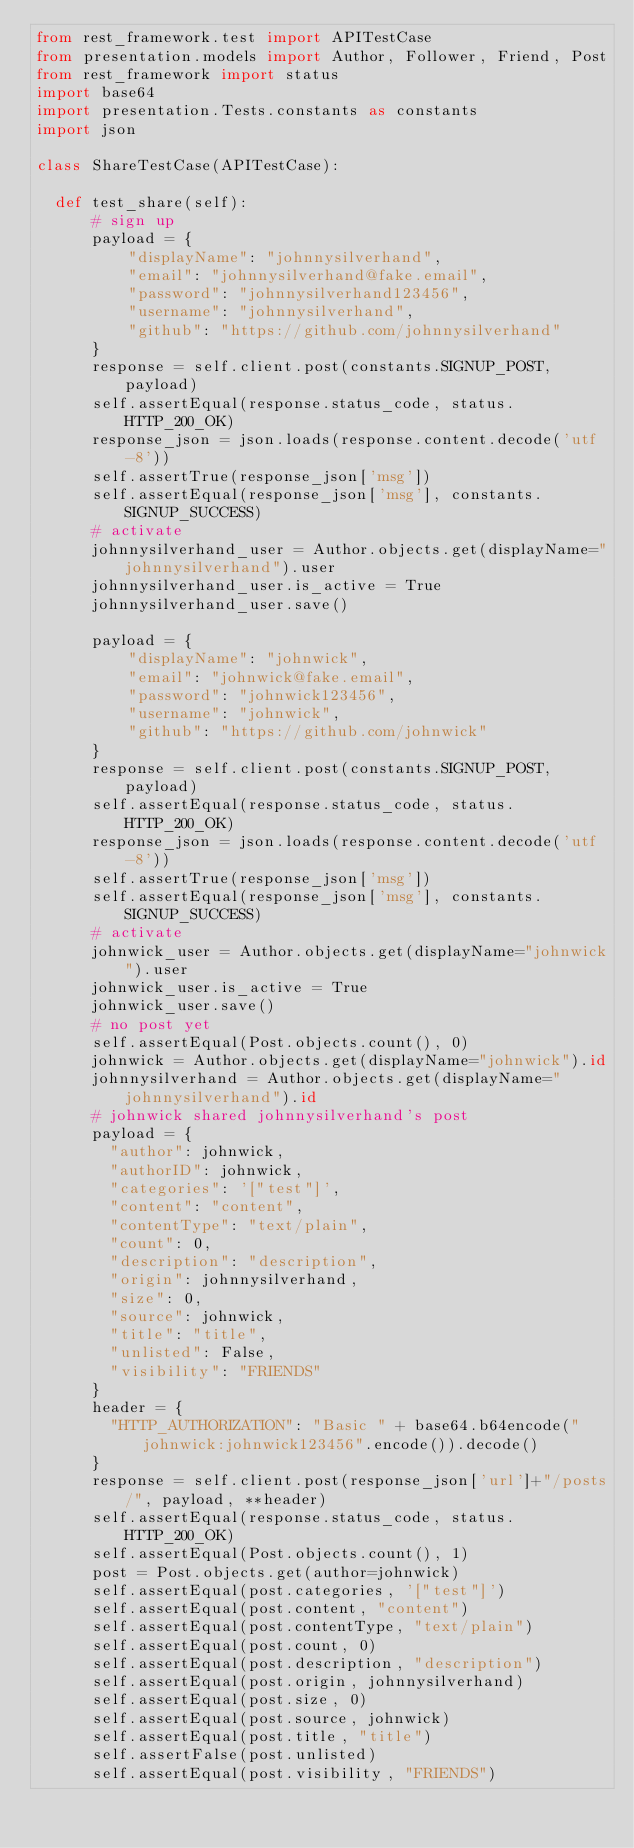Convert code to text. <code><loc_0><loc_0><loc_500><loc_500><_Python_>from rest_framework.test import APITestCase
from presentation.models import Author, Follower, Friend, Post
from rest_framework import status
import base64
import presentation.Tests.constants as constants
import json

class ShareTestCase(APITestCase):

  def test_share(self):
      # sign up
      payload = {
          "displayName": "johnnysilverhand",
          "email": "johnnysilverhand@fake.email",
          "password": "johnnysilverhand123456",
          "username": "johnnysilverhand",
          "github": "https://github.com/johnnysilverhand"
      }
      response = self.client.post(constants.SIGNUP_POST, payload)
      self.assertEqual(response.status_code, status.HTTP_200_OK)
      response_json = json.loads(response.content.decode('utf-8'))
      self.assertTrue(response_json['msg'])
      self.assertEqual(response_json['msg'], constants.SIGNUP_SUCCESS)
      # activate
      johnnysilverhand_user = Author.objects.get(displayName="johnnysilverhand").user
      johnnysilverhand_user.is_active = True
      johnnysilverhand_user.save()

      payload = {
          "displayName": "johnwick",
          "email": "johnwick@fake.email",
          "password": "johnwick123456",
          "username": "johnwick",
          "github": "https://github.com/johnwick"
      }
      response = self.client.post(constants.SIGNUP_POST, payload)
      self.assertEqual(response.status_code, status.HTTP_200_OK)
      response_json = json.loads(response.content.decode('utf-8'))
      self.assertTrue(response_json['msg'])
      self.assertEqual(response_json['msg'], constants.SIGNUP_SUCCESS)
      # activate
      johnwick_user = Author.objects.get(displayName="johnwick").user
      johnwick_user.is_active = True
      johnwick_user.save()
      # no post yet
      self.assertEqual(Post.objects.count(), 0)
      johnwick = Author.objects.get(displayName="johnwick").id
      johnnysilverhand = Author.objects.get(displayName="johnnysilverhand").id
      # johnwick shared johnnysilverhand's post
      payload = {
        "author": johnwick,
        "authorID": johnwick,
        "categories": '["test"]',
        "content": "content",
        "contentType": "text/plain",
        "count": 0,
        "description": "description",
        "origin": johnnysilverhand,
        "size": 0,
        "source": johnwick,
        "title": "title",
        "unlisted": False,
        "visibility": "FRIENDS"
      }
      header = {
        "HTTP_AUTHORIZATION": "Basic " + base64.b64encode("johnwick:johnwick123456".encode()).decode()
      }
      response = self.client.post(response_json['url']+"/posts/", payload, **header)
      self.assertEqual(response.status_code, status.HTTP_200_OK)
      self.assertEqual(Post.objects.count(), 1)
      post = Post.objects.get(author=johnwick)
      self.assertEqual(post.categories, '["test"]')
      self.assertEqual(post.content, "content")
      self.assertEqual(post.contentType, "text/plain")
      self.assertEqual(post.count, 0)
      self.assertEqual(post.description, "description")
      self.assertEqual(post.origin, johnnysilverhand)
      self.assertEqual(post.size, 0)
      self.assertEqual(post.source, johnwick)
      self.assertEqual(post.title, "title")
      self.assertFalse(post.unlisted)
      self.assertEqual(post.visibility, "FRIENDS")</code> 